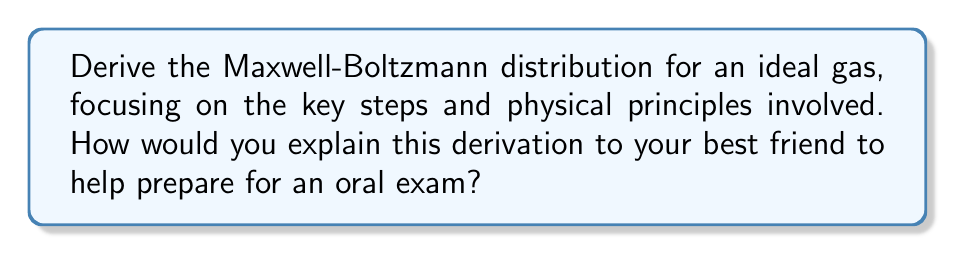Give your solution to this math problem. Let's break down the derivation of the Maxwell-Boltzmann distribution for an ideal gas step-by-step:

1. Start with the assumption of an ideal gas in thermal equilibrium.

2. Consider the probability of finding a particle with momentum between $\mathbf{p}$ and $\mathbf{p} + d\mathbf{p}$:

   $$f(\mathbf{p})d\mathbf{p} = Ae^{-\beta E(\mathbf{p})}d\mathbf{p}$$

   where $A$ is a normalization constant, $\beta = \frac{1}{k_BT}$, and $E(\mathbf{p})$ is the energy of the particle.

3. For an ideal gas, the energy is purely kinetic:

   $$E(\mathbf{p}) = \frac{\mathbf{p}^2}{2m}$$

4. Substitute this into the probability distribution:

   $$f(\mathbf{p})d\mathbf{p} = Ae^{-\beta \frac{\mathbf{p}^2}{2m}}d\mathbf{p}$$

5. Express the distribution in terms of velocity $\mathbf{v}$ instead of momentum:

   $$f(\mathbf{v})d\mathbf{v} = Ae^{-\beta \frac{m\mathbf{v}^2}{2}}d\mathbf{v}$$

6. The distribution must be normalized:

   $$\int_{-\infty}^{\infty} \int_{-\infty}^{\infty} \int_{-\infty}^{\infty} f(\mathbf{v})d\mathbf{v} = 1$$

7. Solve for the normalization constant $A$:

   $$A = \left(\frac{\beta m}{2\pi}\right)^{3/2}$$

8. Substitute back into the distribution:

   $$f(\mathbf{v}) = \left(\frac{m}{2\pi k_BT}\right)^{3/2} e^{-\frac{m\mathbf{v}^2}{2k_BT}}$$

This is the Maxwell-Boltzmann velocity distribution for an ideal gas in three dimensions.

To explain this to your best friend, emphasize the key physical principles:
- The exponential form comes from the Boltzmann factor, which relates energy to probability.
- The $\mathbf{v}^2$ term in the exponent reflects the quadratic nature of kinetic energy.
- The normalization constant ensures the total probability is 1.
- The distribution depends only on the magnitude of velocity, not its direction, reflecting the isotropy of an ideal gas.
Answer: $$f(\mathbf{v}) = \left(\frac{m}{2\pi k_BT}\right)^{3/2} e^{-\frac{m\mathbf{v}^2}{2k_BT}}$$ 